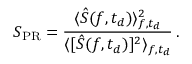<formula> <loc_0><loc_0><loc_500><loc_500>S _ { P R } = \frac { \langle \hat { S } ( f , t _ { d } ) \rangle _ { f , t _ { d } } ^ { 2 } } { \langle [ \hat { S } ( f , t _ { d } ) ] ^ { 2 } \rangle _ { f , t _ { d } } } \, .</formula> 